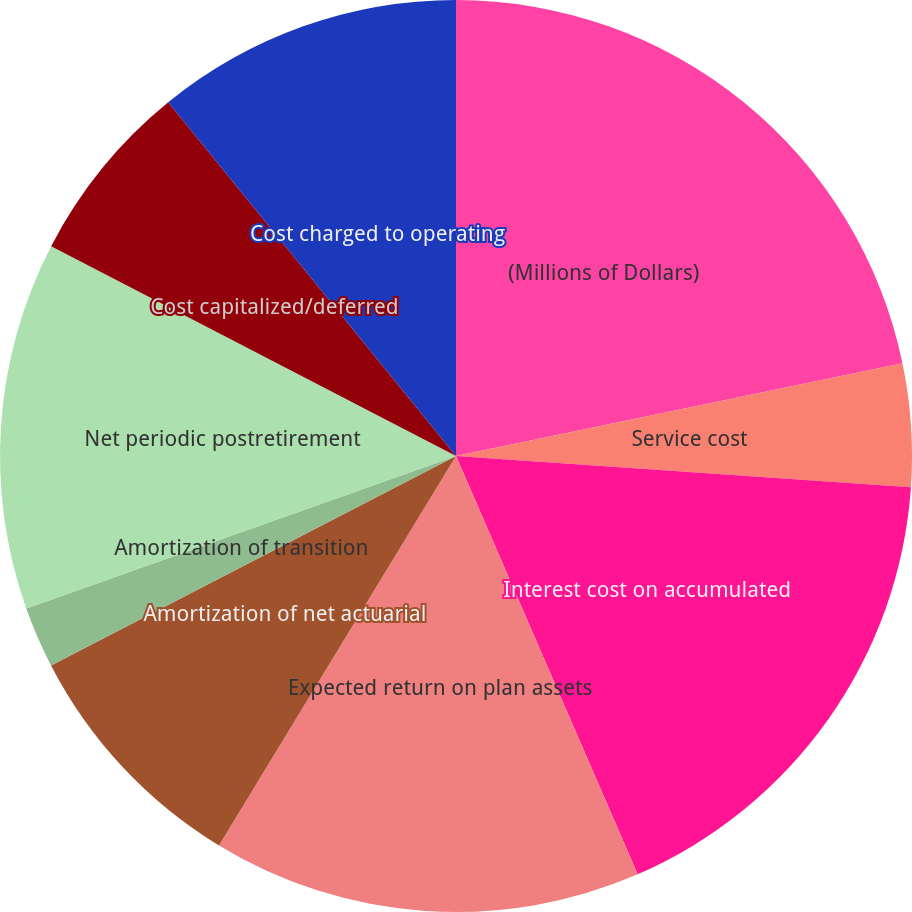Convert chart. <chart><loc_0><loc_0><loc_500><loc_500><pie_chart><fcel>(Millions of Dollars)<fcel>Service cost<fcel>Interest cost on accumulated<fcel>Expected return on plan assets<fcel>Amortization of net actuarial<fcel>Amortization of prior service<fcel>Amortization of transition<fcel>Net periodic postretirement<fcel>Cost capitalized/deferred<fcel>Cost charged to operating<nl><fcel>21.74%<fcel>4.35%<fcel>17.39%<fcel>15.22%<fcel>8.7%<fcel>0.0%<fcel>2.17%<fcel>13.04%<fcel>6.52%<fcel>10.87%<nl></chart> 